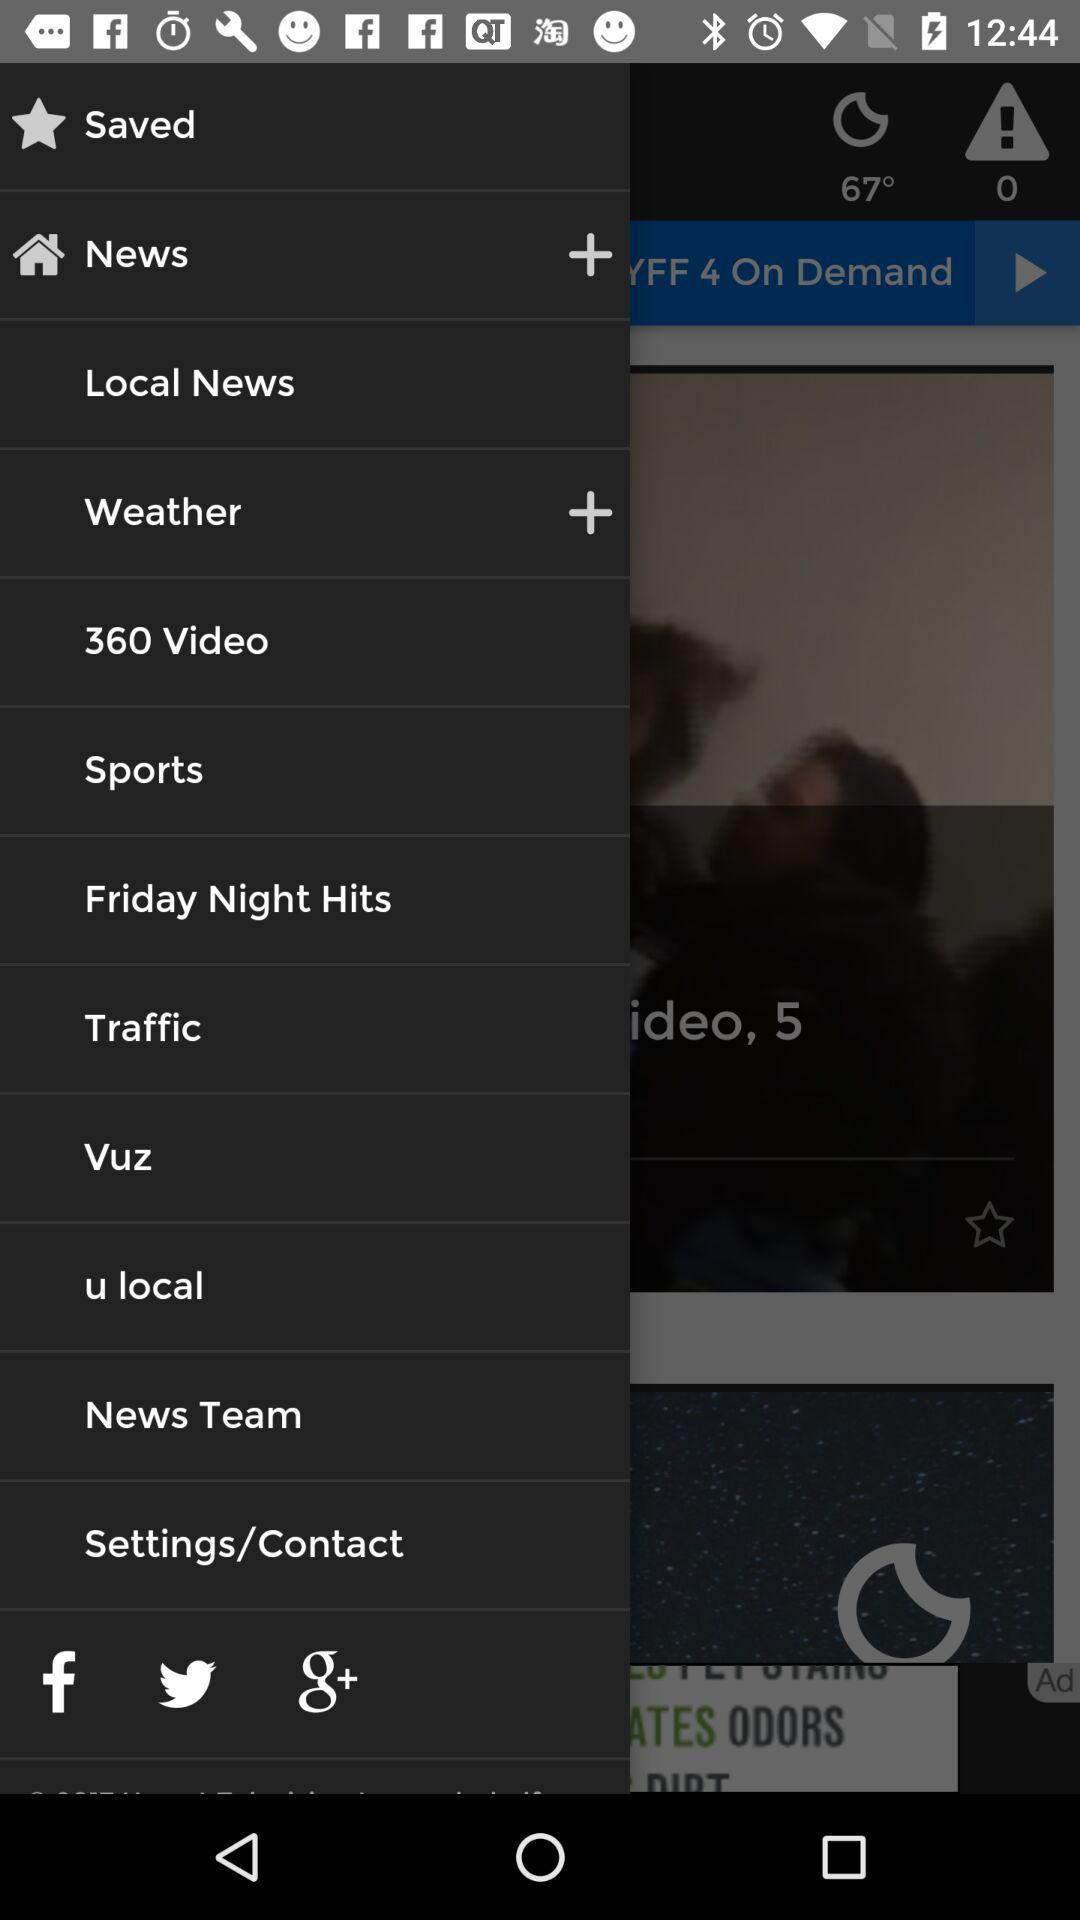What is the temperature? The temperature is 67°. 